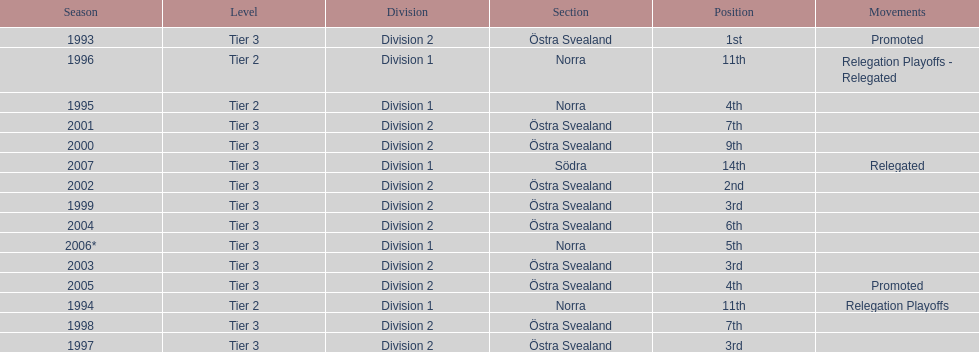How many times did they finish above 5th place in division 2 tier 3? 6. 